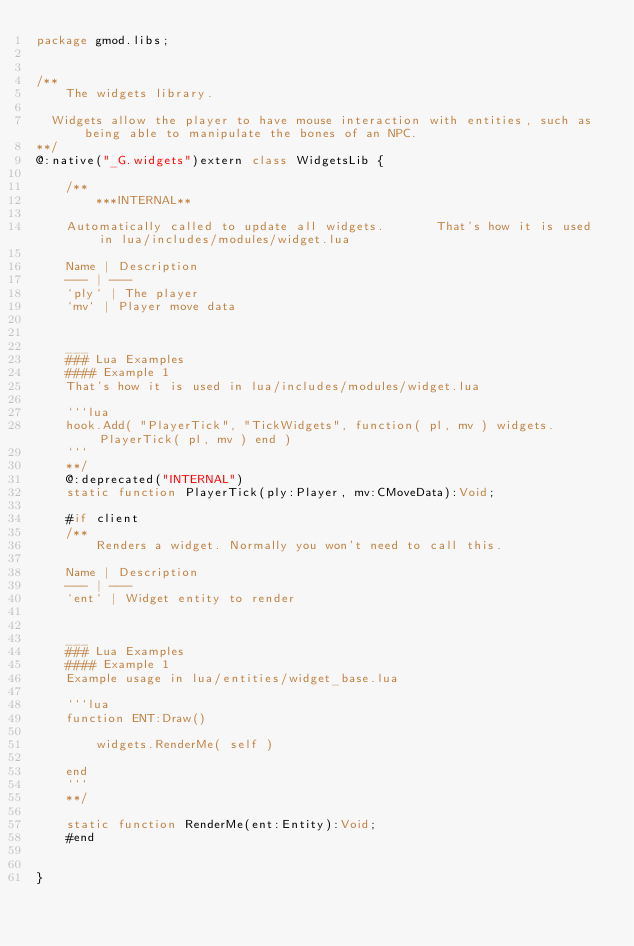Convert code to text. <code><loc_0><loc_0><loc_500><loc_500><_Haxe_>package gmod.libs;


/**
    The widgets library. 
	
	Widgets allow the player to have mouse interaction with entities, such as being able to manipulate the bones of an NPC.
**/
@:native("_G.widgets")extern class WidgetsLib {
    
    /**
        ***INTERNAL** 
		
		Automatically called to update all widgets.       That's how it is used in lua/includes/modules/widget.lua
		
		Name | Description
		--- | ---
		`ply` | The player
		`mv` | Player move data
		
		
		___
		### Lua Examples
		#### Example 1
		That's how it is used in lua/includes/modules/widget.lua
		
		```lua 
		hook.Add( "PlayerTick", "TickWidgets", function( pl, mv ) widgets.PlayerTick( pl, mv ) end )
		```
    **/
    @:deprecated("INTERNAL")
    static function PlayerTick(ply:Player, mv:CMoveData):Void;
    
    #if client
    /**
        Renders a widget. Normally you won't need to call this.
		
		Name | Description
		--- | ---
		`ent` | Widget entity to render
		
		
		___
		### Lua Examples
		#### Example 1
		Example usage in lua/entities/widget_base.lua
		
		```lua 
		function ENT:Draw()
		
		    widgets.RenderMe( self )
		    
		end
		```
    **/
    
    static function RenderMe(ent:Entity):Void;
    #end
    

}



</code> 